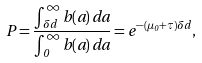Convert formula to latex. <formula><loc_0><loc_0><loc_500><loc_500>P = \frac { \int _ { \delta d } ^ { \infty } b ( a ) \, d a } { \int _ { 0 } ^ { \infty } b ( a ) \, d a } = e ^ { - ( \mu _ { 0 } + \tau ) \delta d } ,</formula> 